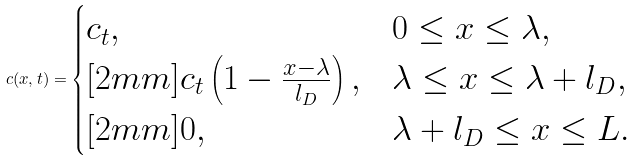<formula> <loc_0><loc_0><loc_500><loc_500>c ( x , t ) = \begin{cases} c _ { t } , & 0 \leq x \leq \lambda , \\ [ 2 m m ] c _ { t } \left ( 1 - \frac { x - \lambda } { l _ { D } } \right ) , & \lambda \leq x \leq \lambda + l _ { D } , \\ [ 2 m m ] 0 , & \lambda + l _ { D } \leq x \leq L . \\ \end{cases}</formula> 